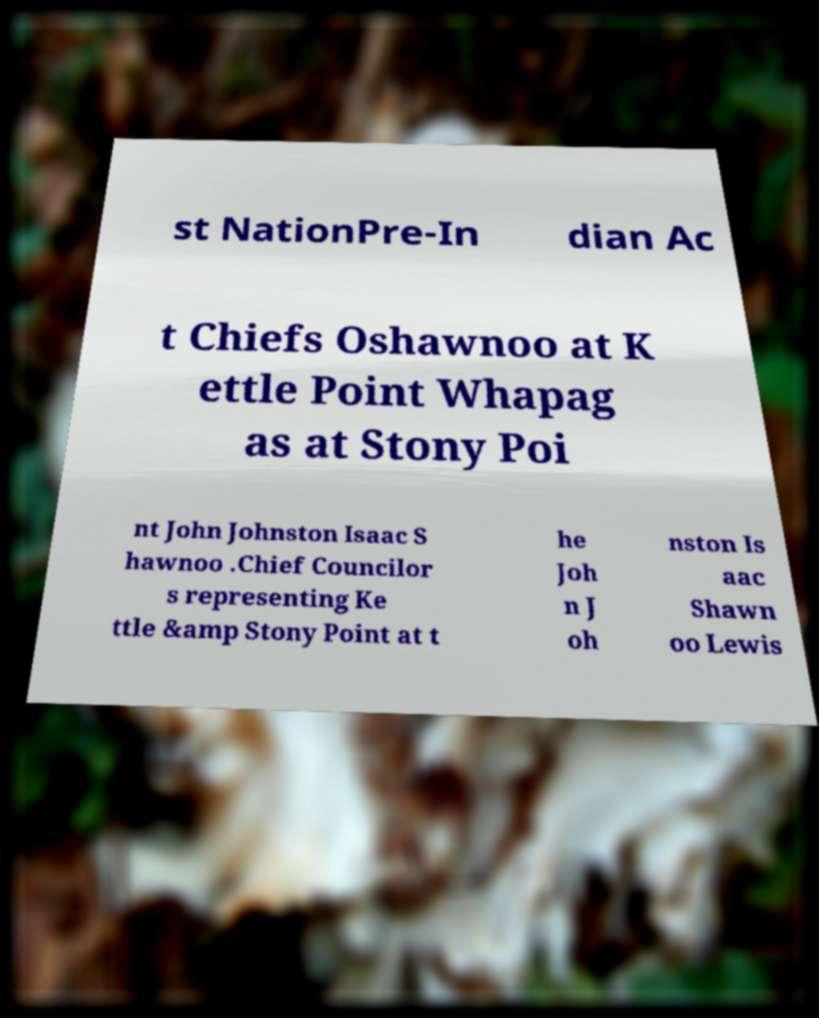Could you assist in decoding the text presented in this image and type it out clearly? st NationPre-In dian Ac t Chiefs Oshawnoo at K ettle Point Whapag as at Stony Poi nt John Johnston Isaac S hawnoo .Chief Councilor s representing Ke ttle &amp Stony Point at t he Joh n J oh nston Is aac Shawn oo Lewis 